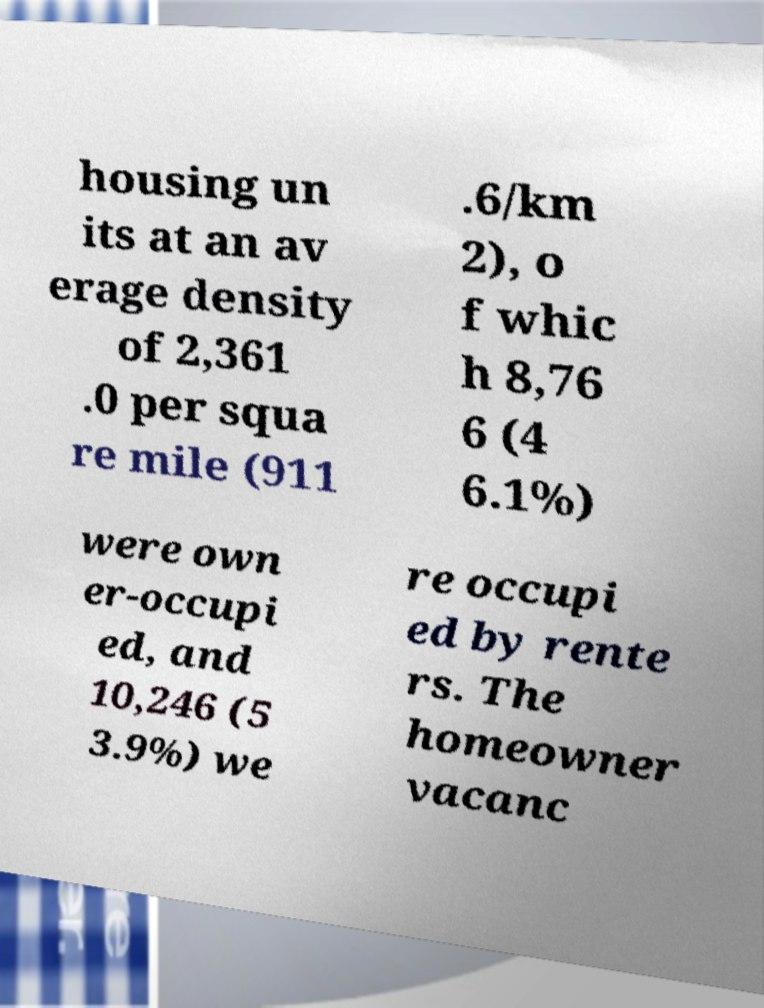Can you accurately transcribe the text from the provided image for me? housing un its at an av erage density of 2,361 .0 per squa re mile (911 .6/km 2), o f whic h 8,76 6 (4 6.1%) were own er-occupi ed, and 10,246 (5 3.9%) we re occupi ed by rente rs. The homeowner vacanc 